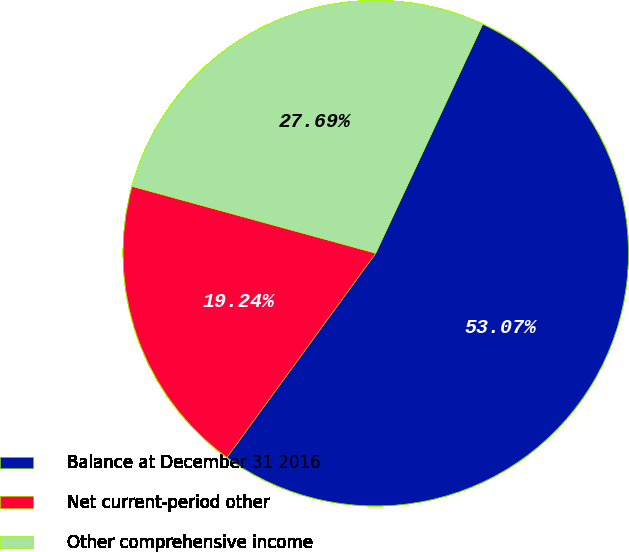Convert chart to OTSL. <chart><loc_0><loc_0><loc_500><loc_500><pie_chart><fcel>Balance at December 31 2016<fcel>Net current-period other<fcel>Other comprehensive income<nl><fcel>53.07%<fcel>19.24%<fcel>27.69%<nl></chart> 